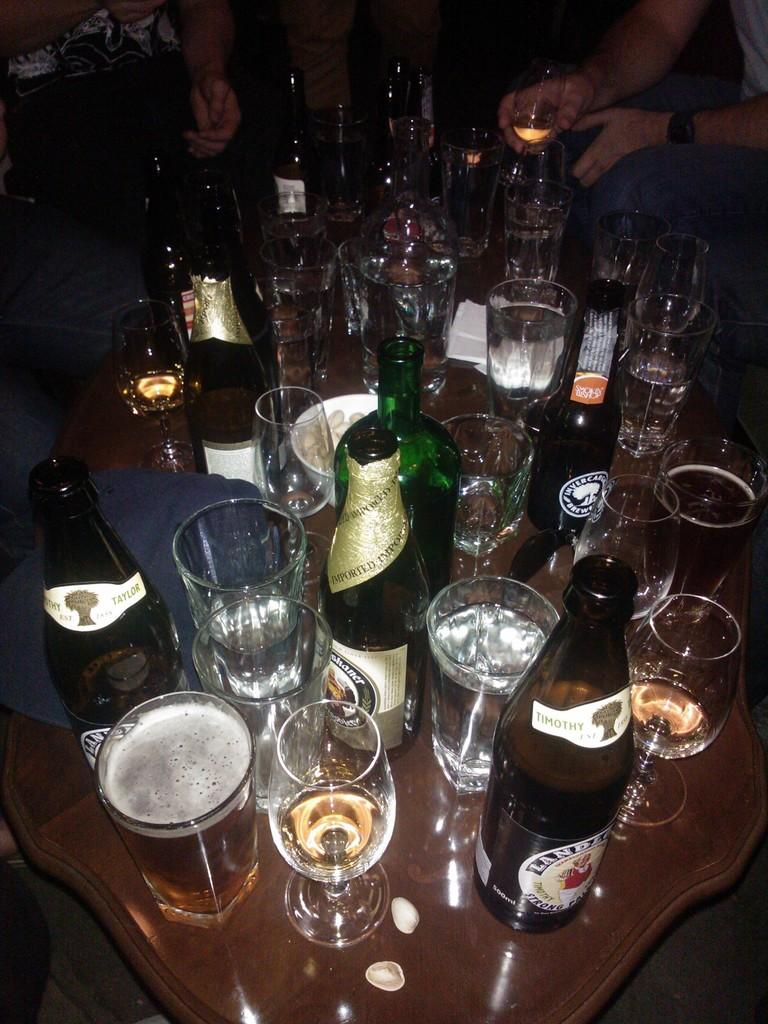What is located in the middle of the image? There is a table in the middle of the image. What objects can be seen on the table? There are bottles, glasses, and bowls on the table. Where are the people in the image? The people are sitting at the top of the image. What are the people holding in the image? The people are holding glasses. Can you see any sea creatures in the image? There are no sea creatures present in the image; it features a table with bottles, glasses, and bowls, along with people sitting and holding glasses. 